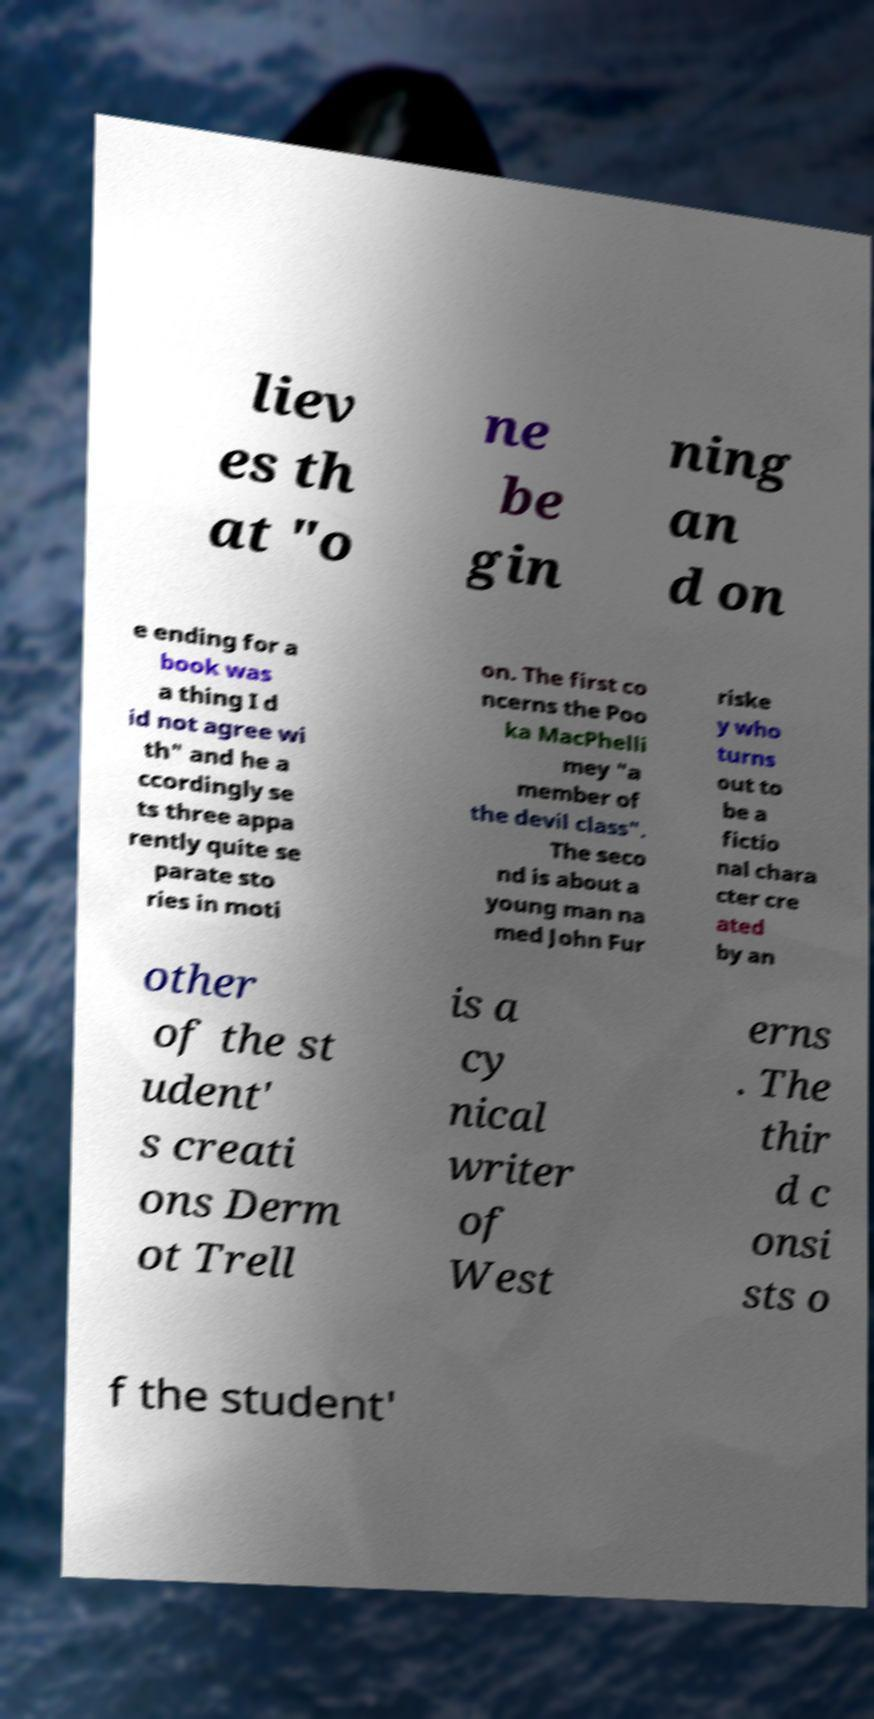I need the written content from this picture converted into text. Can you do that? liev es th at "o ne be gin ning an d on e ending for a book was a thing I d id not agree wi th" and he a ccordingly se ts three appa rently quite se parate sto ries in moti on. The first co ncerns the Poo ka MacPhelli mey "a member of the devil class". The seco nd is about a young man na med John Fur riske y who turns out to be a fictio nal chara cter cre ated by an other of the st udent' s creati ons Derm ot Trell is a cy nical writer of West erns . The thir d c onsi sts o f the student' 